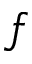Convert formula to latex. <formula><loc_0><loc_0><loc_500><loc_500>f</formula> 